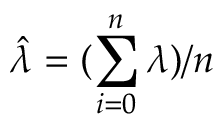Convert formula to latex. <formula><loc_0><loc_0><loc_500><loc_500>\hat { \lambda } = ( \sum _ { i = 0 } ^ { n } \lambda ) / n</formula> 